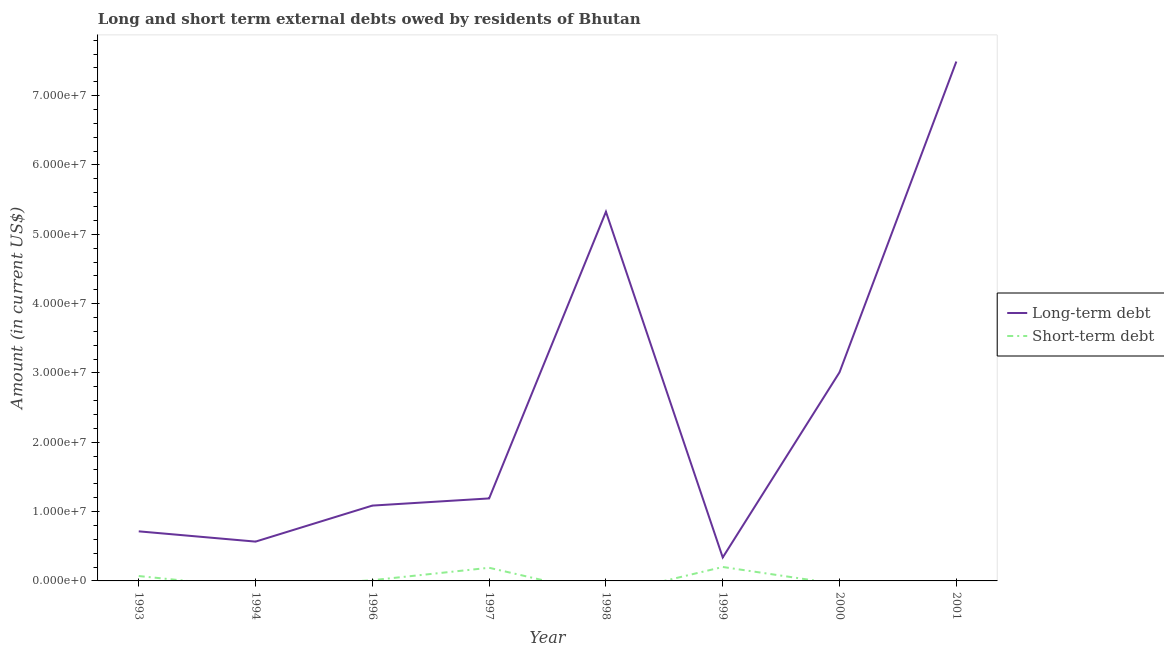How many different coloured lines are there?
Your answer should be compact. 2. Does the line corresponding to short-term debts owed by residents intersect with the line corresponding to long-term debts owed by residents?
Your answer should be very brief. No. Is the number of lines equal to the number of legend labels?
Make the answer very short. No. What is the long-term debts owed by residents in 1994?
Give a very brief answer. 5.67e+06. Across all years, what is the maximum short-term debts owed by residents?
Your answer should be compact. 2.01e+06. Across all years, what is the minimum long-term debts owed by residents?
Ensure brevity in your answer.  3.38e+06. What is the total short-term debts owed by residents in the graph?
Ensure brevity in your answer.  4.71e+06. What is the difference between the long-term debts owed by residents in 1994 and that in 1999?
Your answer should be very brief. 2.28e+06. What is the difference between the long-term debts owed by residents in 2001 and the short-term debts owed by residents in 1993?
Offer a very short reply. 7.42e+07. What is the average short-term debts owed by residents per year?
Your answer should be very brief. 5.89e+05. In the year 1993, what is the difference between the short-term debts owed by residents and long-term debts owed by residents?
Your answer should be compact. -6.45e+06. What is the ratio of the long-term debts owed by residents in 1996 to that in 2001?
Your response must be concise. 0.15. What is the difference between the highest and the second highest short-term debts owed by residents?
Your answer should be compact. 1.14e+05. What is the difference between the highest and the lowest short-term debts owed by residents?
Ensure brevity in your answer.  2.01e+06. Does the short-term debts owed by residents monotonically increase over the years?
Your answer should be very brief. No. Is the long-term debts owed by residents strictly greater than the short-term debts owed by residents over the years?
Offer a terse response. Yes. Is the long-term debts owed by residents strictly less than the short-term debts owed by residents over the years?
Provide a short and direct response. No. How many lines are there?
Offer a very short reply. 2. How many years are there in the graph?
Provide a short and direct response. 8. Are the values on the major ticks of Y-axis written in scientific E-notation?
Offer a very short reply. Yes. Does the graph contain any zero values?
Make the answer very short. Yes. Does the graph contain grids?
Offer a very short reply. No. What is the title of the graph?
Give a very brief answer. Long and short term external debts owed by residents of Bhutan. Does "Working capital" appear as one of the legend labels in the graph?
Your response must be concise. No. What is the Amount (in current US$) of Long-term debt in 1993?
Keep it short and to the point. 7.15e+06. What is the Amount (in current US$) of Short-term debt in 1993?
Provide a short and direct response. 7.03e+05. What is the Amount (in current US$) of Long-term debt in 1994?
Provide a succinct answer. 5.67e+06. What is the Amount (in current US$) of Long-term debt in 1996?
Your answer should be very brief. 1.09e+07. What is the Amount (in current US$) in Short-term debt in 1996?
Offer a terse response. 1.04e+05. What is the Amount (in current US$) in Long-term debt in 1997?
Offer a very short reply. 1.19e+07. What is the Amount (in current US$) in Short-term debt in 1997?
Provide a short and direct response. 1.90e+06. What is the Amount (in current US$) in Long-term debt in 1998?
Keep it short and to the point. 5.33e+07. What is the Amount (in current US$) of Long-term debt in 1999?
Your answer should be very brief. 3.38e+06. What is the Amount (in current US$) in Short-term debt in 1999?
Ensure brevity in your answer.  2.01e+06. What is the Amount (in current US$) of Long-term debt in 2000?
Offer a terse response. 3.01e+07. What is the Amount (in current US$) in Long-term debt in 2001?
Offer a terse response. 7.49e+07. What is the Amount (in current US$) of Short-term debt in 2001?
Your answer should be compact. 0. Across all years, what is the maximum Amount (in current US$) in Long-term debt?
Provide a succinct answer. 7.49e+07. Across all years, what is the maximum Amount (in current US$) of Short-term debt?
Offer a terse response. 2.01e+06. Across all years, what is the minimum Amount (in current US$) of Long-term debt?
Give a very brief answer. 3.38e+06. What is the total Amount (in current US$) in Long-term debt in the graph?
Keep it short and to the point. 1.97e+08. What is the total Amount (in current US$) of Short-term debt in the graph?
Offer a very short reply. 4.71e+06. What is the difference between the Amount (in current US$) in Long-term debt in 1993 and that in 1994?
Provide a short and direct response. 1.48e+06. What is the difference between the Amount (in current US$) in Long-term debt in 1993 and that in 1996?
Your response must be concise. -3.71e+06. What is the difference between the Amount (in current US$) of Short-term debt in 1993 and that in 1996?
Provide a succinct answer. 5.99e+05. What is the difference between the Amount (in current US$) in Long-term debt in 1993 and that in 1997?
Ensure brevity in your answer.  -4.75e+06. What is the difference between the Amount (in current US$) in Short-term debt in 1993 and that in 1997?
Provide a short and direct response. -1.19e+06. What is the difference between the Amount (in current US$) in Long-term debt in 1993 and that in 1998?
Your answer should be very brief. -4.61e+07. What is the difference between the Amount (in current US$) in Long-term debt in 1993 and that in 1999?
Give a very brief answer. 3.77e+06. What is the difference between the Amount (in current US$) of Short-term debt in 1993 and that in 1999?
Provide a short and direct response. -1.31e+06. What is the difference between the Amount (in current US$) in Long-term debt in 1993 and that in 2000?
Offer a very short reply. -2.29e+07. What is the difference between the Amount (in current US$) in Long-term debt in 1993 and that in 2001?
Your response must be concise. -6.78e+07. What is the difference between the Amount (in current US$) of Long-term debt in 1994 and that in 1996?
Make the answer very short. -5.20e+06. What is the difference between the Amount (in current US$) of Long-term debt in 1994 and that in 1997?
Offer a very short reply. -6.23e+06. What is the difference between the Amount (in current US$) in Long-term debt in 1994 and that in 1998?
Your response must be concise. -4.76e+07. What is the difference between the Amount (in current US$) of Long-term debt in 1994 and that in 1999?
Keep it short and to the point. 2.28e+06. What is the difference between the Amount (in current US$) in Long-term debt in 1994 and that in 2000?
Your response must be concise. -2.44e+07. What is the difference between the Amount (in current US$) in Long-term debt in 1994 and that in 2001?
Your response must be concise. -6.92e+07. What is the difference between the Amount (in current US$) of Long-term debt in 1996 and that in 1997?
Offer a terse response. -1.04e+06. What is the difference between the Amount (in current US$) of Short-term debt in 1996 and that in 1997?
Make the answer very short. -1.79e+06. What is the difference between the Amount (in current US$) of Long-term debt in 1996 and that in 1998?
Provide a succinct answer. -4.24e+07. What is the difference between the Amount (in current US$) of Long-term debt in 1996 and that in 1999?
Offer a terse response. 7.48e+06. What is the difference between the Amount (in current US$) of Short-term debt in 1996 and that in 1999?
Offer a terse response. -1.91e+06. What is the difference between the Amount (in current US$) in Long-term debt in 1996 and that in 2000?
Your answer should be very brief. -1.92e+07. What is the difference between the Amount (in current US$) in Long-term debt in 1996 and that in 2001?
Provide a succinct answer. -6.41e+07. What is the difference between the Amount (in current US$) in Long-term debt in 1997 and that in 1998?
Keep it short and to the point. -4.14e+07. What is the difference between the Amount (in current US$) in Long-term debt in 1997 and that in 1999?
Ensure brevity in your answer.  8.52e+06. What is the difference between the Amount (in current US$) of Short-term debt in 1997 and that in 1999?
Offer a terse response. -1.14e+05. What is the difference between the Amount (in current US$) of Long-term debt in 1997 and that in 2000?
Make the answer very short. -1.82e+07. What is the difference between the Amount (in current US$) of Long-term debt in 1997 and that in 2001?
Give a very brief answer. -6.30e+07. What is the difference between the Amount (in current US$) in Long-term debt in 1998 and that in 1999?
Provide a succinct answer. 4.99e+07. What is the difference between the Amount (in current US$) of Long-term debt in 1998 and that in 2000?
Offer a very short reply. 2.32e+07. What is the difference between the Amount (in current US$) in Long-term debt in 1998 and that in 2001?
Provide a succinct answer. -2.17e+07. What is the difference between the Amount (in current US$) in Long-term debt in 1999 and that in 2000?
Provide a succinct answer. -2.67e+07. What is the difference between the Amount (in current US$) in Long-term debt in 1999 and that in 2001?
Make the answer very short. -7.15e+07. What is the difference between the Amount (in current US$) of Long-term debt in 2000 and that in 2001?
Provide a short and direct response. -4.48e+07. What is the difference between the Amount (in current US$) of Long-term debt in 1993 and the Amount (in current US$) of Short-term debt in 1996?
Your answer should be compact. 7.05e+06. What is the difference between the Amount (in current US$) in Long-term debt in 1993 and the Amount (in current US$) in Short-term debt in 1997?
Ensure brevity in your answer.  5.26e+06. What is the difference between the Amount (in current US$) in Long-term debt in 1993 and the Amount (in current US$) in Short-term debt in 1999?
Give a very brief answer. 5.14e+06. What is the difference between the Amount (in current US$) in Long-term debt in 1994 and the Amount (in current US$) in Short-term debt in 1996?
Your response must be concise. 5.57e+06. What is the difference between the Amount (in current US$) of Long-term debt in 1994 and the Amount (in current US$) of Short-term debt in 1997?
Ensure brevity in your answer.  3.77e+06. What is the difference between the Amount (in current US$) of Long-term debt in 1994 and the Amount (in current US$) of Short-term debt in 1999?
Your answer should be very brief. 3.66e+06. What is the difference between the Amount (in current US$) of Long-term debt in 1996 and the Amount (in current US$) of Short-term debt in 1997?
Offer a terse response. 8.97e+06. What is the difference between the Amount (in current US$) of Long-term debt in 1996 and the Amount (in current US$) of Short-term debt in 1999?
Offer a very short reply. 8.86e+06. What is the difference between the Amount (in current US$) of Long-term debt in 1997 and the Amount (in current US$) of Short-term debt in 1999?
Offer a terse response. 9.89e+06. What is the difference between the Amount (in current US$) in Long-term debt in 1998 and the Amount (in current US$) in Short-term debt in 1999?
Offer a very short reply. 5.12e+07. What is the average Amount (in current US$) of Long-term debt per year?
Offer a terse response. 2.47e+07. What is the average Amount (in current US$) of Short-term debt per year?
Your answer should be very brief. 5.89e+05. In the year 1993, what is the difference between the Amount (in current US$) in Long-term debt and Amount (in current US$) in Short-term debt?
Your response must be concise. 6.45e+06. In the year 1996, what is the difference between the Amount (in current US$) in Long-term debt and Amount (in current US$) in Short-term debt?
Offer a very short reply. 1.08e+07. In the year 1997, what is the difference between the Amount (in current US$) of Long-term debt and Amount (in current US$) of Short-term debt?
Your answer should be compact. 1.00e+07. In the year 1999, what is the difference between the Amount (in current US$) in Long-term debt and Amount (in current US$) in Short-term debt?
Your answer should be very brief. 1.38e+06. What is the ratio of the Amount (in current US$) in Long-term debt in 1993 to that in 1994?
Provide a succinct answer. 1.26. What is the ratio of the Amount (in current US$) in Long-term debt in 1993 to that in 1996?
Give a very brief answer. 0.66. What is the ratio of the Amount (in current US$) in Short-term debt in 1993 to that in 1996?
Your response must be concise. 6.76. What is the ratio of the Amount (in current US$) of Long-term debt in 1993 to that in 1997?
Keep it short and to the point. 0.6. What is the ratio of the Amount (in current US$) of Short-term debt in 1993 to that in 1997?
Make the answer very short. 0.37. What is the ratio of the Amount (in current US$) in Long-term debt in 1993 to that in 1998?
Your answer should be compact. 0.13. What is the ratio of the Amount (in current US$) in Long-term debt in 1993 to that in 1999?
Your response must be concise. 2.11. What is the ratio of the Amount (in current US$) of Short-term debt in 1993 to that in 1999?
Your answer should be compact. 0.35. What is the ratio of the Amount (in current US$) in Long-term debt in 1993 to that in 2000?
Your response must be concise. 0.24. What is the ratio of the Amount (in current US$) of Long-term debt in 1993 to that in 2001?
Provide a short and direct response. 0.1. What is the ratio of the Amount (in current US$) of Long-term debt in 1994 to that in 1996?
Offer a terse response. 0.52. What is the ratio of the Amount (in current US$) in Long-term debt in 1994 to that in 1997?
Your answer should be very brief. 0.48. What is the ratio of the Amount (in current US$) of Long-term debt in 1994 to that in 1998?
Provide a short and direct response. 0.11. What is the ratio of the Amount (in current US$) in Long-term debt in 1994 to that in 1999?
Offer a very short reply. 1.68. What is the ratio of the Amount (in current US$) in Long-term debt in 1994 to that in 2000?
Provide a succinct answer. 0.19. What is the ratio of the Amount (in current US$) in Long-term debt in 1994 to that in 2001?
Make the answer very short. 0.08. What is the ratio of the Amount (in current US$) of Long-term debt in 1996 to that in 1997?
Offer a very short reply. 0.91. What is the ratio of the Amount (in current US$) of Short-term debt in 1996 to that in 1997?
Offer a very short reply. 0.05. What is the ratio of the Amount (in current US$) in Long-term debt in 1996 to that in 1998?
Make the answer very short. 0.2. What is the ratio of the Amount (in current US$) of Long-term debt in 1996 to that in 1999?
Your response must be concise. 3.21. What is the ratio of the Amount (in current US$) in Short-term debt in 1996 to that in 1999?
Offer a very short reply. 0.05. What is the ratio of the Amount (in current US$) of Long-term debt in 1996 to that in 2000?
Offer a very short reply. 0.36. What is the ratio of the Amount (in current US$) of Long-term debt in 1996 to that in 2001?
Your answer should be compact. 0.14. What is the ratio of the Amount (in current US$) in Long-term debt in 1997 to that in 1998?
Ensure brevity in your answer.  0.22. What is the ratio of the Amount (in current US$) in Long-term debt in 1997 to that in 1999?
Offer a very short reply. 3.52. What is the ratio of the Amount (in current US$) of Short-term debt in 1997 to that in 1999?
Give a very brief answer. 0.94. What is the ratio of the Amount (in current US$) of Long-term debt in 1997 to that in 2000?
Make the answer very short. 0.4. What is the ratio of the Amount (in current US$) of Long-term debt in 1997 to that in 2001?
Make the answer very short. 0.16. What is the ratio of the Amount (in current US$) of Long-term debt in 1998 to that in 1999?
Make the answer very short. 15.73. What is the ratio of the Amount (in current US$) in Long-term debt in 1998 to that in 2000?
Offer a very short reply. 1.77. What is the ratio of the Amount (in current US$) of Long-term debt in 1998 to that in 2001?
Your answer should be very brief. 0.71. What is the ratio of the Amount (in current US$) of Long-term debt in 1999 to that in 2000?
Provide a succinct answer. 0.11. What is the ratio of the Amount (in current US$) of Long-term debt in 1999 to that in 2001?
Provide a succinct answer. 0.05. What is the ratio of the Amount (in current US$) in Long-term debt in 2000 to that in 2001?
Your answer should be compact. 0.4. What is the difference between the highest and the second highest Amount (in current US$) in Long-term debt?
Make the answer very short. 2.17e+07. What is the difference between the highest and the second highest Amount (in current US$) of Short-term debt?
Keep it short and to the point. 1.14e+05. What is the difference between the highest and the lowest Amount (in current US$) in Long-term debt?
Your answer should be compact. 7.15e+07. What is the difference between the highest and the lowest Amount (in current US$) in Short-term debt?
Make the answer very short. 2.01e+06. 